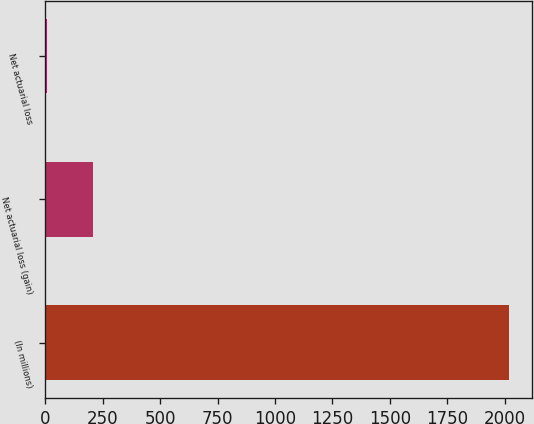Convert chart. <chart><loc_0><loc_0><loc_500><loc_500><bar_chart><fcel>(In millions)<fcel>Net actuarial loss (gain)<fcel>Net actuarial loss<nl><fcel>2018<fcel>209<fcel>8<nl></chart> 